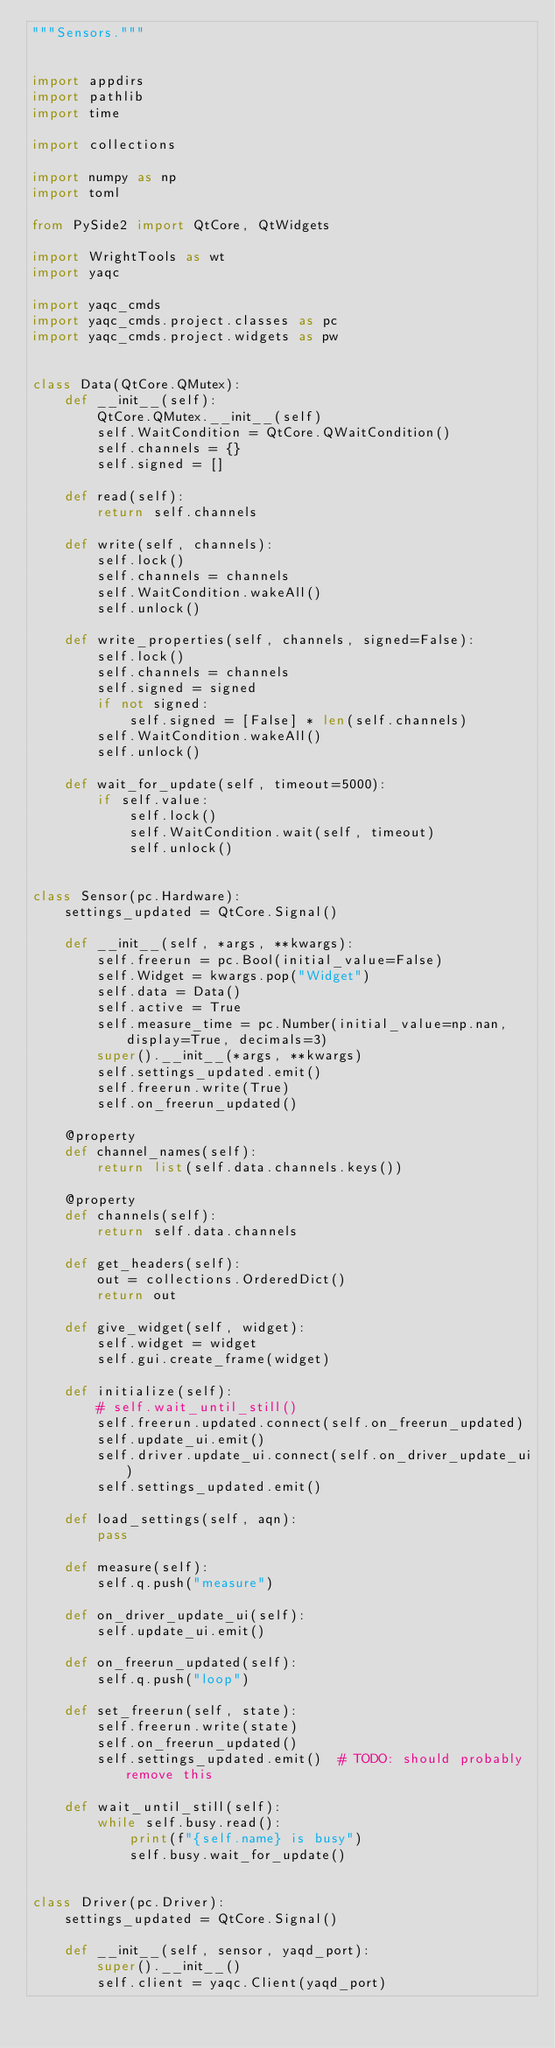Convert code to text. <code><loc_0><loc_0><loc_500><loc_500><_Python_>"""Sensors."""


import appdirs
import pathlib
import time

import collections

import numpy as np
import toml

from PySide2 import QtCore, QtWidgets

import WrightTools as wt
import yaqc

import yaqc_cmds
import yaqc_cmds.project.classes as pc
import yaqc_cmds.project.widgets as pw


class Data(QtCore.QMutex):
    def __init__(self):
        QtCore.QMutex.__init__(self)
        self.WaitCondition = QtCore.QWaitCondition()
        self.channels = {}
        self.signed = []

    def read(self):
        return self.channels

    def write(self, channels):
        self.lock()
        self.channels = channels
        self.WaitCondition.wakeAll()
        self.unlock()

    def write_properties(self, channels, signed=False):
        self.lock()
        self.channels = channels
        self.signed = signed
        if not signed:
            self.signed = [False] * len(self.channels)
        self.WaitCondition.wakeAll()
        self.unlock()

    def wait_for_update(self, timeout=5000):
        if self.value:
            self.lock()
            self.WaitCondition.wait(self, timeout)
            self.unlock()


class Sensor(pc.Hardware):
    settings_updated = QtCore.Signal()

    def __init__(self, *args, **kwargs):
        self.freerun = pc.Bool(initial_value=False)
        self.Widget = kwargs.pop("Widget")
        self.data = Data()
        self.active = True
        self.measure_time = pc.Number(initial_value=np.nan, display=True, decimals=3)
        super().__init__(*args, **kwargs)
        self.settings_updated.emit()
        self.freerun.write(True)
        self.on_freerun_updated()

    @property
    def channel_names(self):
        return list(self.data.channels.keys())

    @property
    def channels(self):
        return self.data.channels

    def get_headers(self):
        out = collections.OrderedDict()
        return out

    def give_widget(self, widget):
        self.widget = widget
        self.gui.create_frame(widget)

    def initialize(self):
        # self.wait_until_still()
        self.freerun.updated.connect(self.on_freerun_updated)
        self.update_ui.emit()
        self.driver.update_ui.connect(self.on_driver_update_ui)
        self.settings_updated.emit()

    def load_settings(self, aqn):
        pass

    def measure(self):
        self.q.push("measure")

    def on_driver_update_ui(self):
        self.update_ui.emit()

    def on_freerun_updated(self):
        self.q.push("loop")

    def set_freerun(self, state):
        self.freerun.write(state)
        self.on_freerun_updated()
        self.settings_updated.emit()  # TODO: should probably remove this

    def wait_until_still(self):
        while self.busy.read():
            print(f"{self.name} is busy")
            self.busy.wait_for_update()


class Driver(pc.Driver):
    settings_updated = QtCore.Signal()

    def __init__(self, sensor, yaqd_port):
        super().__init__()
        self.client = yaqc.Client(yaqd_port)</code> 